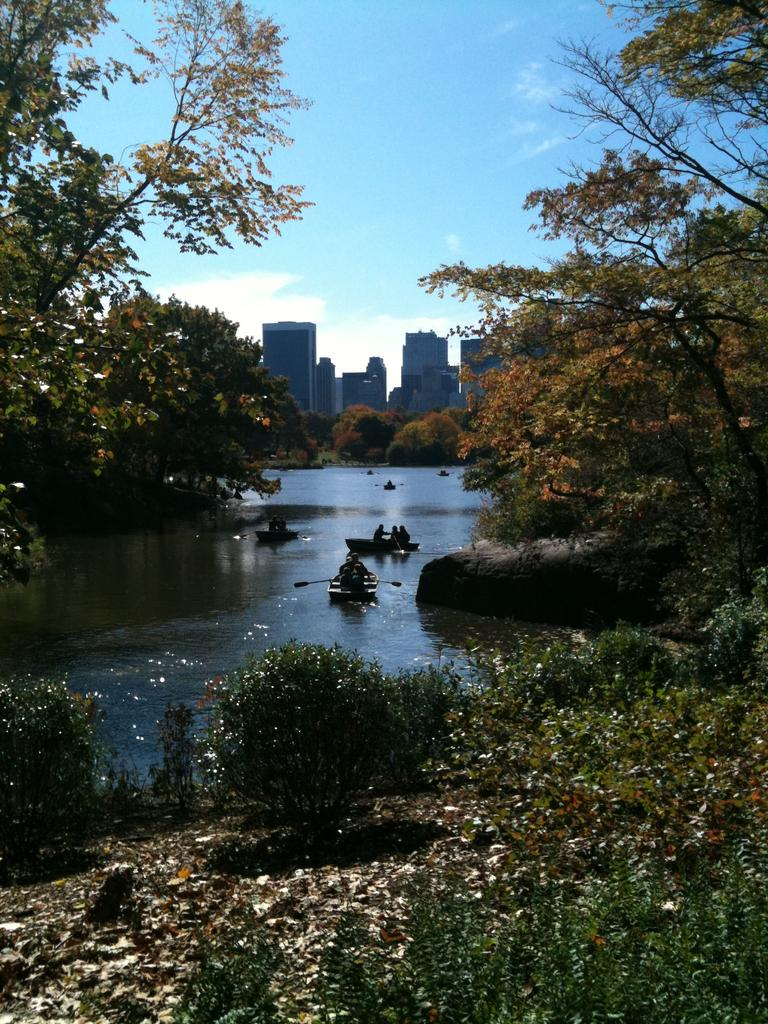What are the people in the image doing? The people in the image are on two boats that are rafting on the water. What is the setting of the image? The boats are rafting on the water, with trees around the water and buildings in the background. What type of dinner is being served on the boats in the image? There is no dinner being served on the boats in the image; the people are rafting on the water. 